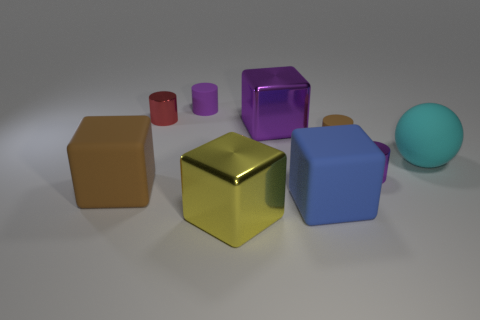Are there any small cylinders that have the same color as the sphere?
Make the answer very short. No. There is a brown thing that is to the right of the metallic block that is in front of the large matte thing that is left of the purple cube; what size is it?
Keep it short and to the point. Small. The yellow thing has what shape?
Provide a succinct answer. Cube. There is a brown matte thing on the left side of the tiny purple matte cylinder; how many brown matte things are left of it?
Keep it short and to the point. 0. How many other objects are there of the same material as the small red thing?
Offer a very short reply. 3. Is the material of the large cyan sphere in front of the red object the same as the brown object behind the big cyan object?
Keep it short and to the point. Yes. Are there any other things that are the same shape as the large cyan matte object?
Give a very brief answer. No. Is the big yellow cube made of the same material as the small purple object that is right of the yellow metal cube?
Provide a succinct answer. Yes. The big shiny block that is in front of the brown object behind the tiny purple object that is to the right of the large blue block is what color?
Provide a succinct answer. Yellow. What is the shape of the purple shiny thing that is the same size as the red shiny object?
Offer a very short reply. Cylinder. 